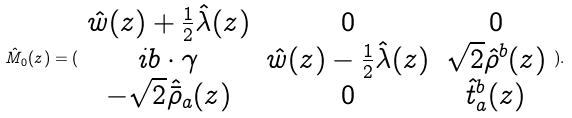Convert formula to latex. <formula><loc_0><loc_0><loc_500><loc_500>\hat { M } _ { 0 } ( z ) = ( \begin{array} { c c c } \hat { w } ( z ) + \frac { 1 } { 2 } \hat { \lambda } ( z ) & 0 & 0 \\ i b \cdot \gamma & \hat { w } ( z ) - \frac { 1 } { 2 } \hat { \lambda } ( z ) & \sqrt { 2 } \hat { \rho } ^ { b } ( z ) \\ - \sqrt { 2 } \hat { \bar { \rho } } _ { a } ( z ) & 0 & \hat { t } _ { a } ^ { b } ( z ) \end{array} ) .</formula> 